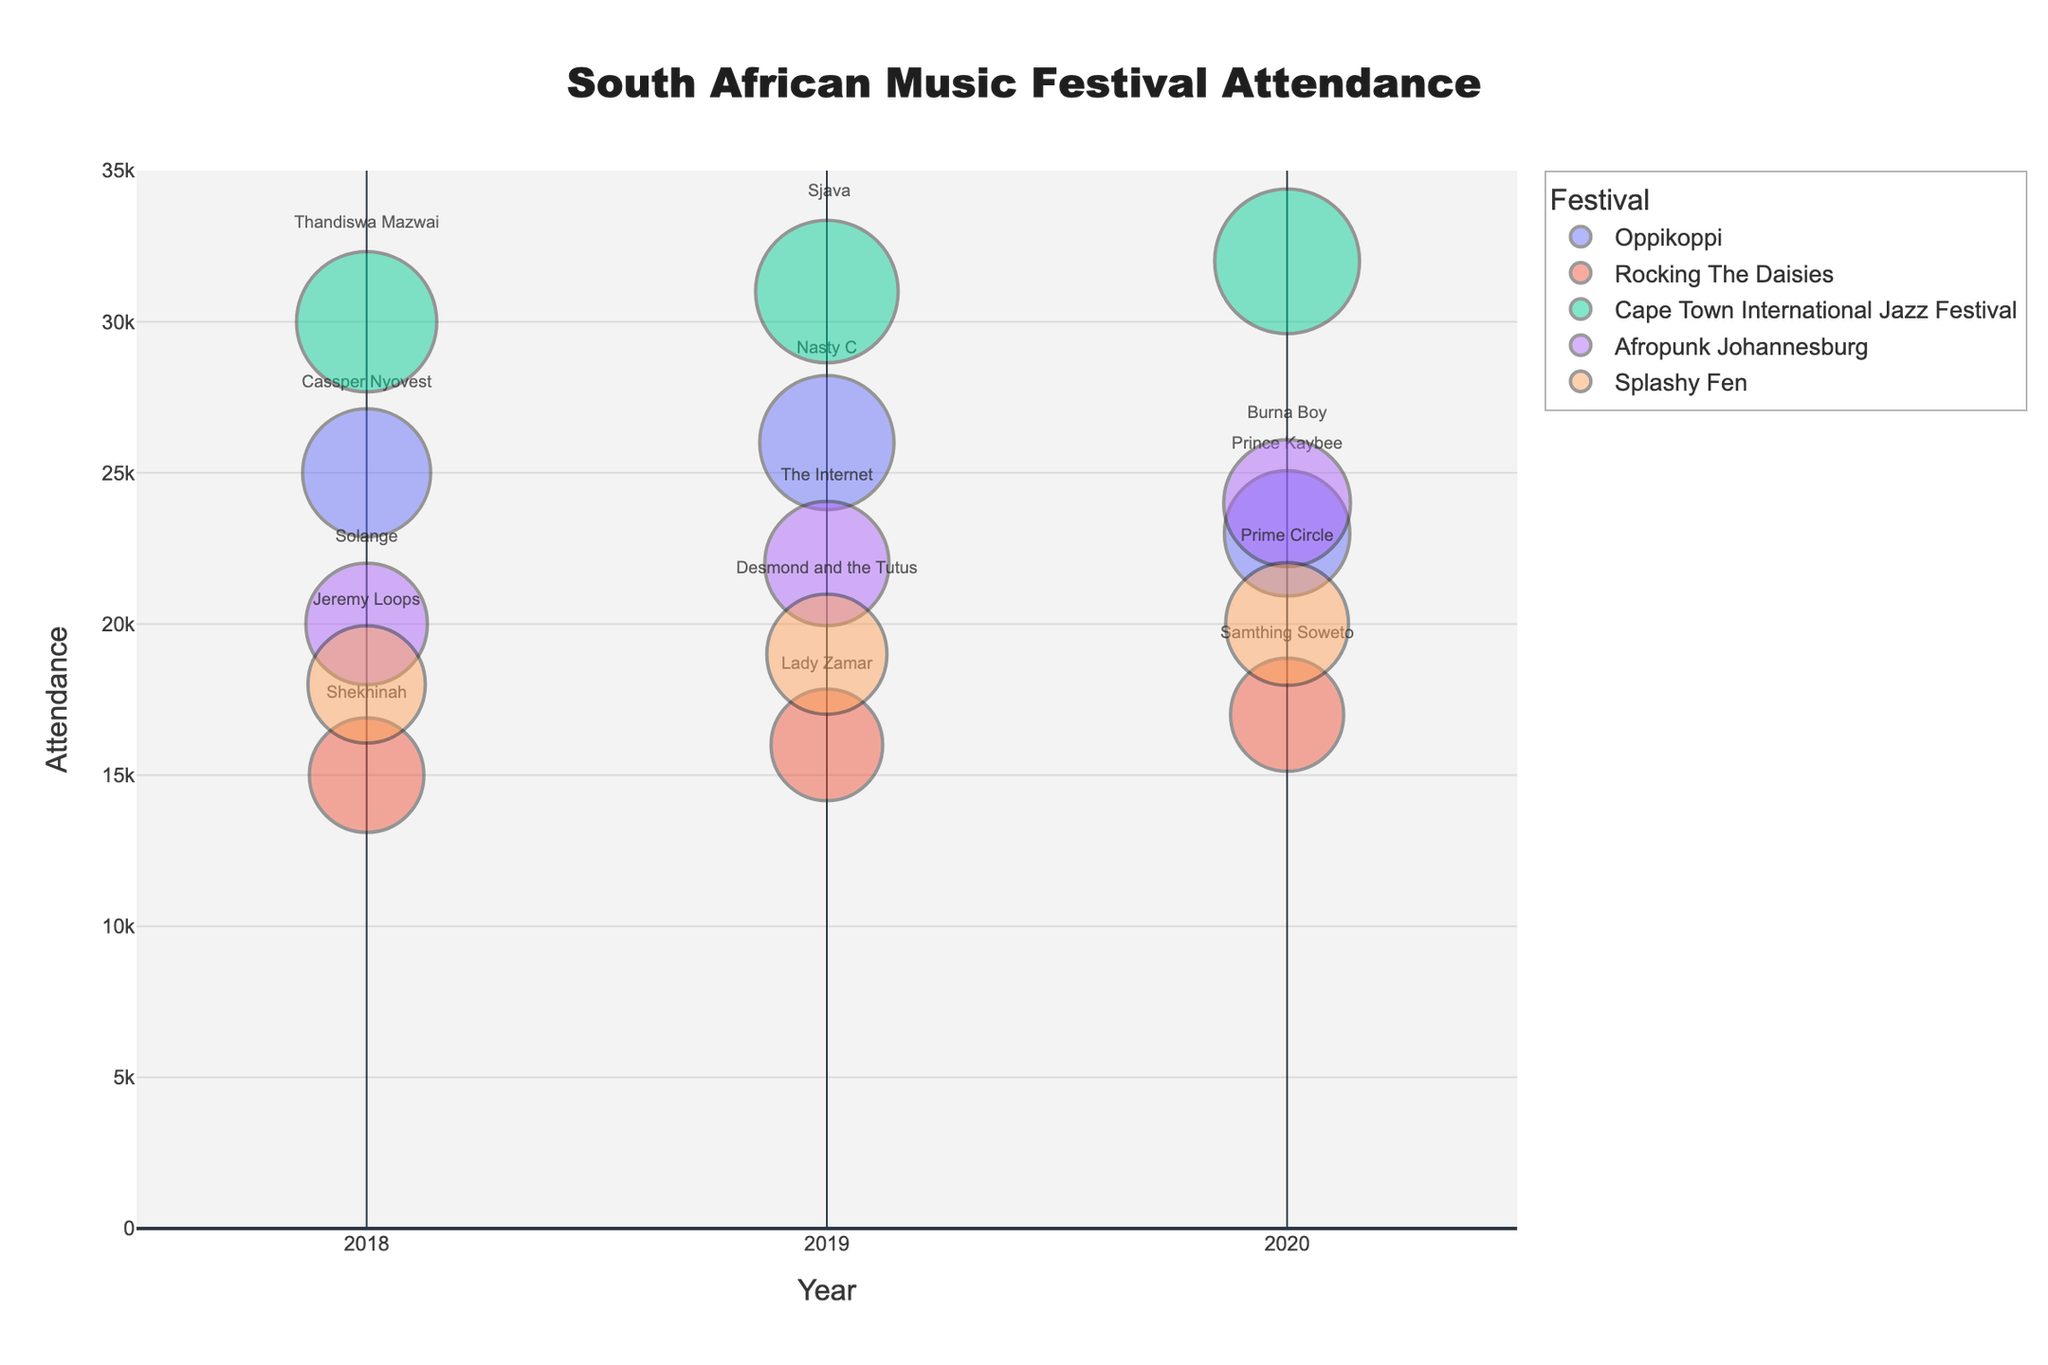Which festival had the highest attendance in 2020? Look at the attendance figures for the year 2020 and find the highest value. 'Cape Town International Jazz Festival' has the largest bubble size, indicating an attendance of 32,000.
Answer: Cape Town International Jazz Festival What is the trend in attendance for Oppikoppi festival from 2018 to 2020? Observe the bubbles labeled 'Oppikoppi' in 2018, 2019, and 2020. Attendance goes from 25,000 in 2018 to 26,000 in 2019 and then drops to 23,000 in 2020.
Answer: Increased then decreased How did the attendance at Rocking The Daisies change from 2018 to 2020? Check the sizes of the bubbles for 'Rocking The Daisies' in 2018, 2019, and 2020. Attendance was 15,000 in 2018, 16,000 in 2019, and 17,000 in 2020.
Answer: It increased Which artist headlined the 2019 Cape Town International Jazz Festival? Look at the text label within the bubble for 'Cape Town International Jazz Festival' in 2019. The headline artist is Sjava.
Answer: Sjava Which festival had the lowest attendance in 2019? Compare the sizes of the bubbles for all festivals in 2019. 'Rocking The Daisies' has the smallest bubble, indicating an attendance of 16,000.
Answer: Rocking The Daisies What is the average attendance of Afropunk Johannesburg over the three years? Sum the attendance for Afropunk Johannesburg in 2018, 2019, and 2020, and then divide by 3. (20,000 + 22,000 + 24,000) / 3 = 22,000.
Answer: 22,000 Which festival had a continuous increase in attendance over the three years? Look at the attendance figures for each festival across 2018, 2019, and 2020. 'Cape Town International Jazz Festival' shows a continuous increase: 30,000, 31,000, and 32,000.
Answer: Cape Town International Jazz Festival Among the artists listed, who headlined multiple festivals over the three years? Check the lineup for each year and see if an artist appears more than once. 'Sho Madjozi' performed at 'Afropunk Johannesburg' in 2018 and 'Splashy Fen' in 2020.
Answer: Sho Madjozi 